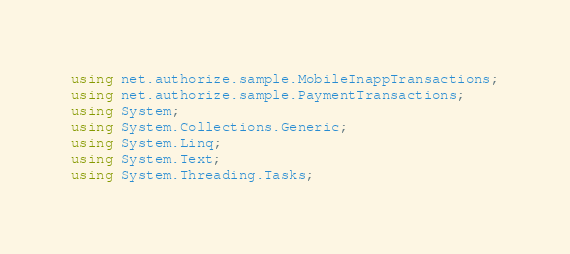Convert code to text. <code><loc_0><loc_0><loc_500><loc_500><_C#_>using net.authorize.sample.MobileInappTransactions;
using net.authorize.sample.PaymentTransactions;
using System;
using System.Collections.Generic;
using System.Linq;
using System.Text;
using System.Threading.Tasks;</code> 